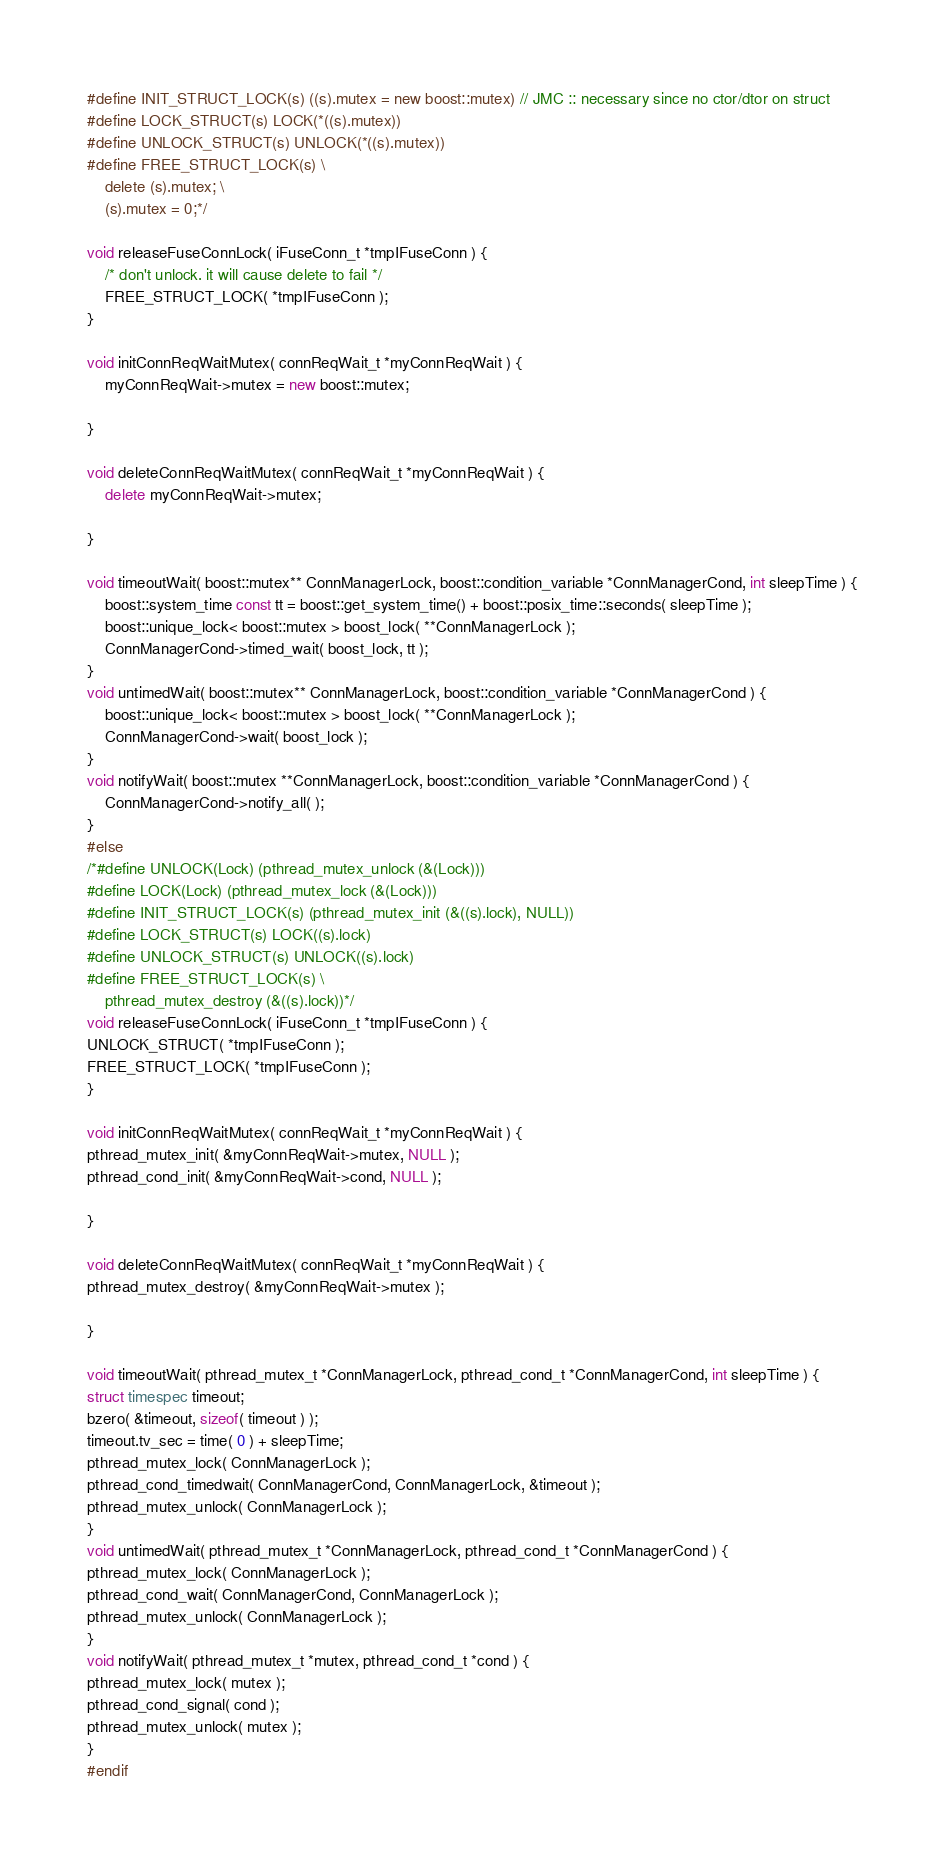Convert code to text. <code><loc_0><loc_0><loc_500><loc_500><_C++_>#define INIT_STRUCT_LOCK(s) ((s).mutex = new boost::mutex) // JMC :: necessary since no ctor/dtor on struct
#define LOCK_STRUCT(s) LOCK(*((s).mutex))
#define UNLOCK_STRUCT(s) UNLOCK(*((s).mutex))
#define FREE_STRUCT_LOCK(s) \
    delete (s).mutex; \
    (s).mutex = 0;*/

void releaseFuseConnLock( iFuseConn_t *tmpIFuseConn ) {
    /* don't unlock. it will cause delete to fail */
    FREE_STRUCT_LOCK( *tmpIFuseConn );
}

void initConnReqWaitMutex( connReqWait_t *myConnReqWait ) {
    myConnReqWait->mutex = new boost::mutex;

}

void deleteConnReqWaitMutex( connReqWait_t *myConnReqWait ) {
    delete myConnReqWait->mutex;

}

void timeoutWait( boost::mutex** ConnManagerLock, boost::condition_variable *ConnManagerCond, int sleepTime ) {
    boost::system_time const tt = boost::get_system_time() + boost::posix_time::seconds( sleepTime );
    boost::unique_lock< boost::mutex > boost_lock( **ConnManagerLock );
    ConnManagerCond->timed_wait( boost_lock, tt );
}
void untimedWait( boost::mutex** ConnManagerLock, boost::condition_variable *ConnManagerCond ) {
    boost::unique_lock< boost::mutex > boost_lock( **ConnManagerLock );
    ConnManagerCond->wait( boost_lock );
}
void notifyWait( boost::mutex **ConnManagerLock, boost::condition_variable *ConnManagerCond ) {
    ConnManagerCond->notify_all( );
}
#else
/*#define UNLOCK(Lock) (pthread_mutex_unlock (&(Lock)))
#define LOCK(Lock) (pthread_mutex_lock (&(Lock)))
#define INIT_STRUCT_LOCK(s) (pthread_mutex_init (&((s).lock), NULL))
#define LOCK_STRUCT(s) LOCK((s).lock)
#define UNLOCK_STRUCT(s) UNLOCK((s).lock)
#define FREE_STRUCT_LOCK(s) \
    pthread_mutex_destroy (&((s).lock))*/
void releaseFuseConnLock( iFuseConn_t *tmpIFuseConn ) {
UNLOCK_STRUCT( *tmpIFuseConn );
FREE_STRUCT_LOCK( *tmpIFuseConn );
}

void initConnReqWaitMutex( connReqWait_t *myConnReqWait ) {
pthread_mutex_init( &myConnReqWait->mutex, NULL );
pthread_cond_init( &myConnReqWait->cond, NULL );

}

void deleteConnReqWaitMutex( connReqWait_t *myConnReqWait ) {
pthread_mutex_destroy( &myConnReqWait->mutex );

}

void timeoutWait( pthread_mutex_t *ConnManagerLock, pthread_cond_t *ConnManagerCond, int sleepTime ) {
struct timespec timeout;
bzero( &timeout, sizeof( timeout ) );
timeout.tv_sec = time( 0 ) + sleepTime;
pthread_mutex_lock( ConnManagerLock );
pthread_cond_timedwait( ConnManagerCond, ConnManagerLock, &timeout );
pthread_mutex_unlock( ConnManagerLock );
}
void untimedWait( pthread_mutex_t *ConnManagerLock, pthread_cond_t *ConnManagerCond ) {
pthread_mutex_lock( ConnManagerLock );
pthread_cond_wait( ConnManagerCond, ConnManagerLock );
pthread_mutex_unlock( ConnManagerLock );
}
void notifyWait( pthread_mutex_t *mutex, pthread_cond_t *cond ) {
pthread_mutex_lock( mutex );
pthread_cond_signal( cond );
pthread_mutex_unlock( mutex );
}
#endif
</code> 